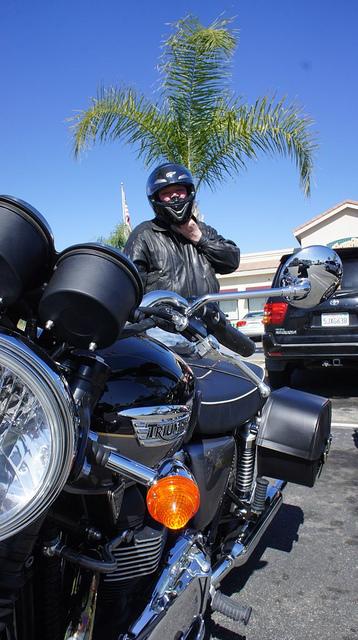Is that a palm tree?
Answer briefly. Yes. What kind of vehicle is parked behind the motorcycle?
Short answer required. Suv. What type of motorcycle helmet is present?
Be succinct. Full face. 